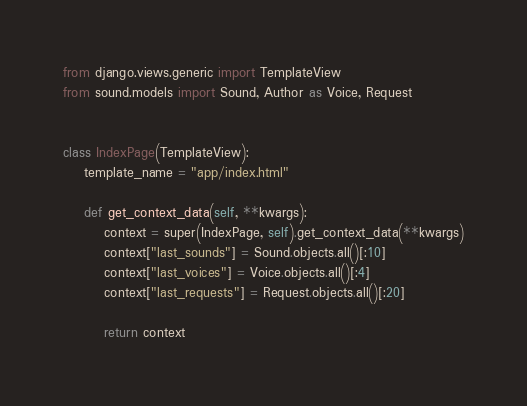Convert code to text. <code><loc_0><loc_0><loc_500><loc_500><_Python_>from django.views.generic import TemplateView
from sound.models import Sound, Author as Voice, Request


class IndexPage(TemplateView):
    template_name = "app/index.html"

    def get_context_data(self, **kwargs):
        context = super(IndexPage, self).get_context_data(**kwargs)
        context["last_sounds"] = Sound.objects.all()[:10]
        context["last_voices"] = Voice.objects.all()[:4]
        context["last_requests"] = Request.objects.all()[:20]

        return context</code> 